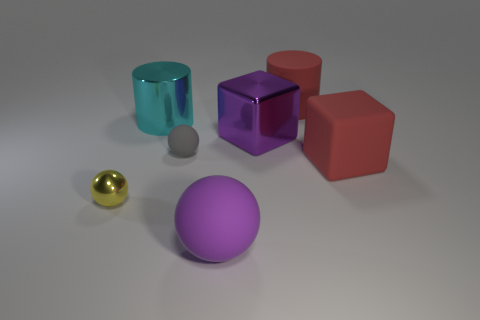How many things are things that are on the left side of the tiny gray object or purple things that are to the right of the purple ball?
Provide a short and direct response. 3. How many objects are either metallic spheres or purple shiny things?
Provide a short and direct response. 2. There is a big red cylinder that is right of the large metal cube; what number of small balls are in front of it?
Your response must be concise. 2. How many other objects are the same size as the shiny cylinder?
Your answer should be very brief. 4. The block that is the same color as the large sphere is what size?
Offer a very short reply. Large. Do the small thing that is behind the large matte cube and the tiny yellow object have the same shape?
Your response must be concise. Yes. What material is the purple object in front of the small yellow metal object?
Give a very brief answer. Rubber. What is the shape of the large object that is the same color as the metal cube?
Provide a succinct answer. Sphere. Is there a large purple object made of the same material as the gray thing?
Your answer should be very brief. Yes. The yellow shiny object is what size?
Provide a short and direct response. Small. 